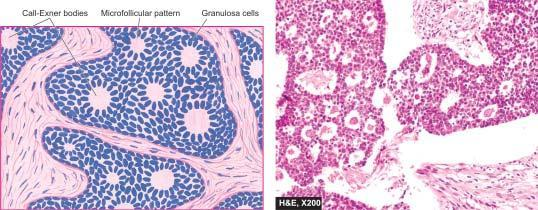did granulosa cell tumour show uniform granulosa cells and numerous rosette-like call-exner bodies containing central amorphous pink material surrounded by granulosa cells?
Answer the question using a single word or phrase. Yes 